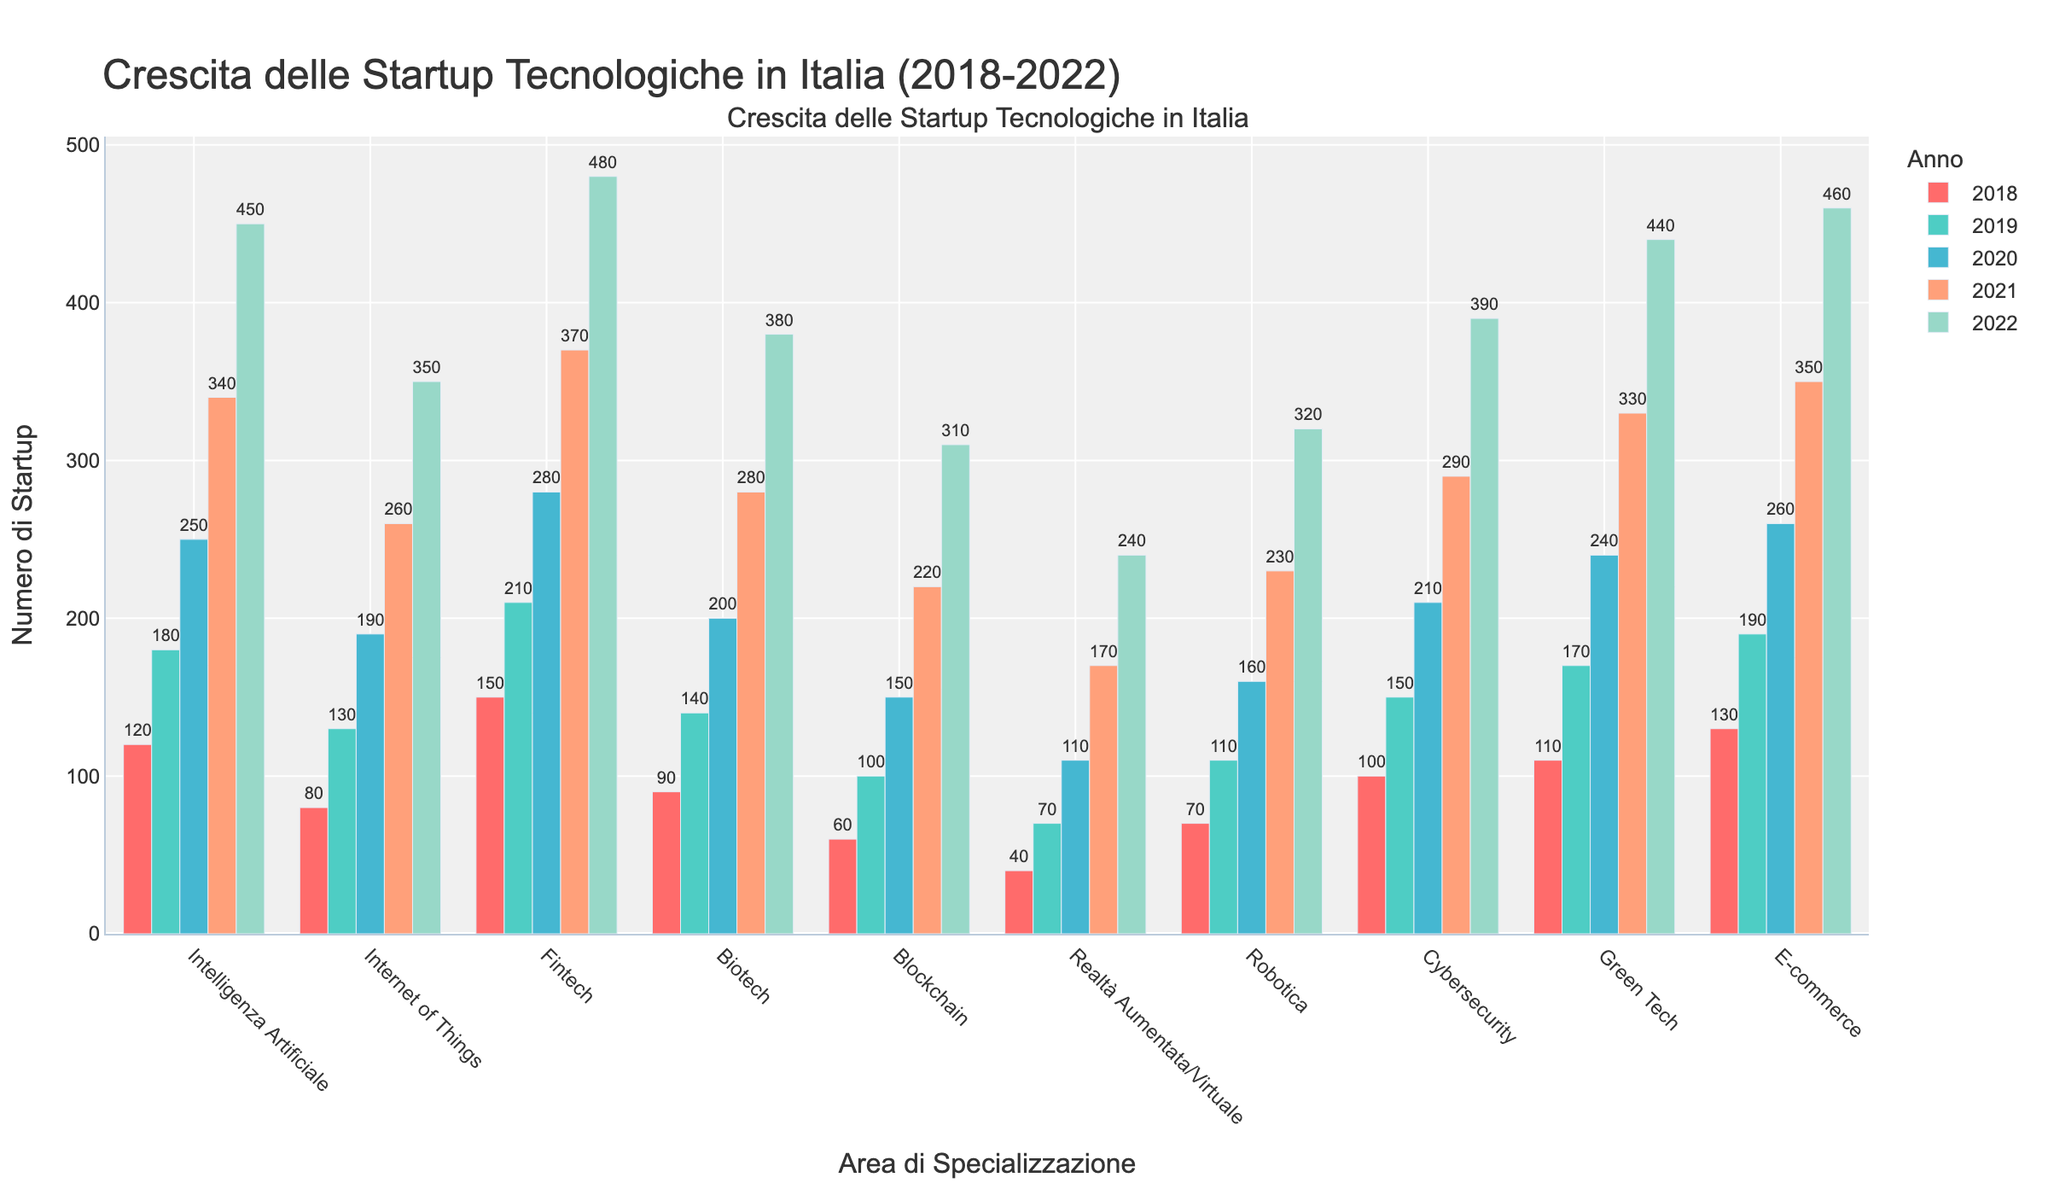1. Quale area di specializzazione ha avuto la maggiore crescita dal 2018 al 2022? Osservando l'altezza delle barre, vediamo che tutte le aree di specializzazione sono cresciute nel periodo indicato. Tuttavia, notiamo che Fintech ha avuto la maggiore crescita, passando da 150 startup nel 2018 a 480 nel 2022.
Answer: Fintech 2. Tra Intelligenza Artificiale e Internet of Things, quale area ha avuto più startup nel 2020? Confrontando le barre per il 2020, vediamo che Intelligenza Artificiale ha 250 startup e Internet of Things ne ha 190.
Answer: Intelligenza Artificiale 3. Quanti sono, in media, le startup nelle aree di Green Tech e Cybersecurity nel 2019? Sommando i numeri delle due aree per il 2019 (170 per Green Tech + 150 per Cybersecurity) otteniamo 320. Dividiamo per 2 per ottenere la media: 320 / 2 = 160.
Answer: 160 4. Quale area ha avuto il minor numero di startup nel 2018? Guardando le barre del 2018, vediamo che Realtà Aumentata/Virtuale ha il minor numero di startup con 40.
Answer: Realtà Aumentata/Virtuale 5. Nel 2022, quali due aree hanno un numero di startup molto simile? Osservando le barre del 2022, vediamo che Intelligenza Artificiale ha 450 startup e Green Tech ne ha 440, valori molto vicini tra loro.
Answer: Intelligenza Artificiale e Green Tech 6. Di quanto è cresciuto il numero di startup nel settore Biotech dal 2018 al 2022? Biotech aveva 90 startup nel 2018 e ne ha 380 nel 2022. La crescita è 380 - 90 = 290.
Answer: 290 7. Quale settore ha visto un aumento più significativo tra il 2018 e il 2019? Confrontando la differenza tra i numeri del 2019 e del 2018, Fintech ha visto l'aumento maggiore, con un incremento di 210 - 150 = 60.
Answer: Fintech 8. Quale settore ha meno startup rispetto a Blockchain nel 2021? Nel 2021, Blockchain ha 220 startup. Realtà Aumentata/Virtuale ha solo 170 startup, il che è meno di Blockchain.
Answer: Realtà Aumentata/Virtuale 9. Tra Robotica e Cybersecurity, quale ha avuto una crescita maggiore dal 2018 al 2022? Robotica è passata da 70 a 320 (crescita di 250), mentre Cybersecurity è passata da 100 a 390 (crescita di 290).
Answer: Cybersecurity 10. Quale colore rappresenta l'anno con il maggior numero di startup nel settore E-commerce? Il 2022, rappresentato dal colore utilizzato per il 2022, ha il maggior numero di startup in E-commerce con 460.
Answer: Colore usato per il 2022 